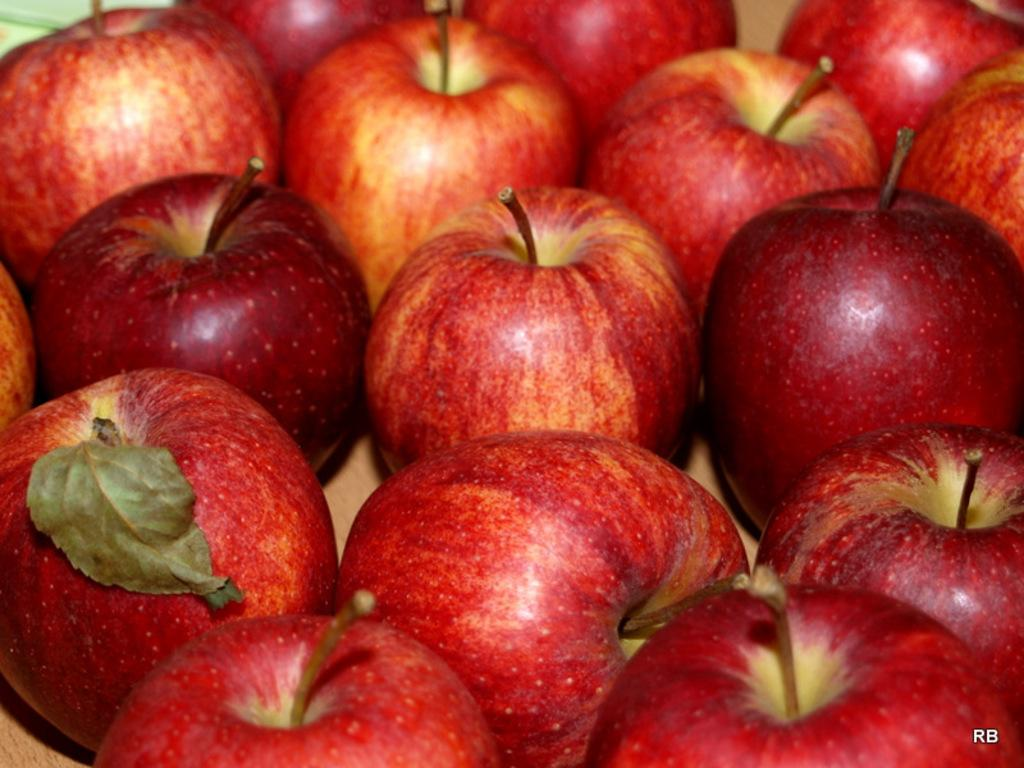What type of fruit is visible in the image? There is a group of apples in the image. Can you describe the arrangement of the apples in the image? The provided facts do not mention the arrangement of the apples, so we cannot describe it. What might be a common use for apples? Apples are often eaten as a snack or used in cooking, such as in pies or sauces. What type of jam can be seen in the image? There is no jam present in the image; it features a group of apples. What shape are the apples in the image? The provided facts do not mention the shape of the apples, so we cannot describe it. 